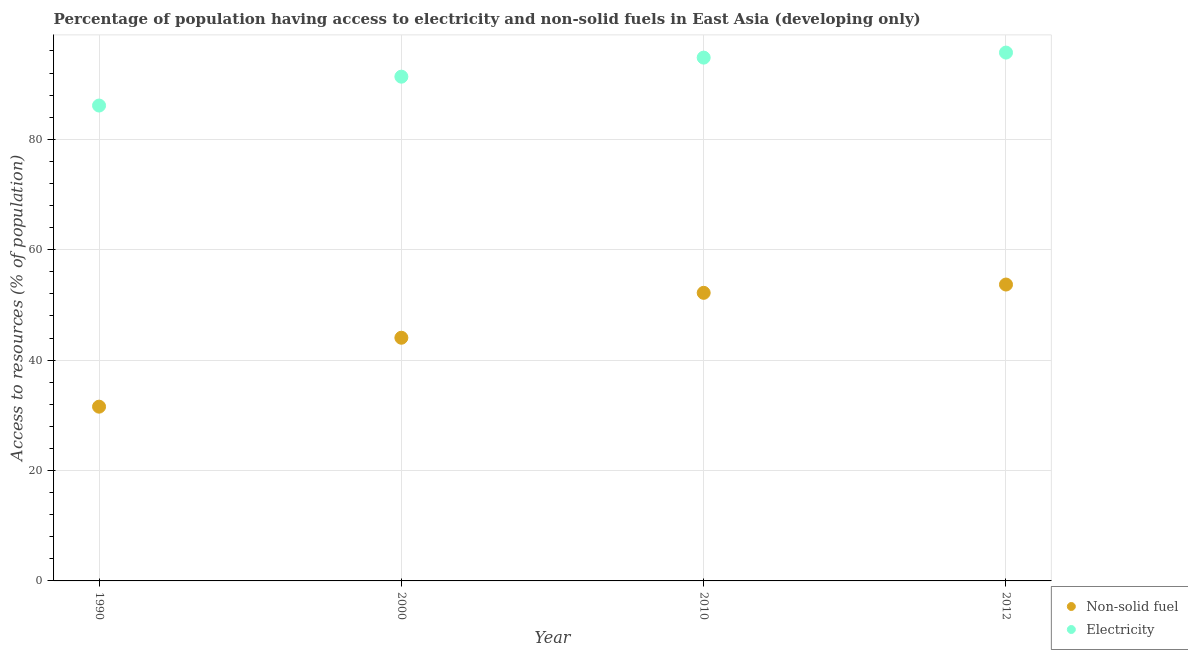What is the percentage of population having access to electricity in 2012?
Your response must be concise. 95.71. Across all years, what is the maximum percentage of population having access to electricity?
Make the answer very short. 95.71. Across all years, what is the minimum percentage of population having access to electricity?
Ensure brevity in your answer.  86.12. In which year was the percentage of population having access to non-solid fuel minimum?
Offer a terse response. 1990. What is the total percentage of population having access to non-solid fuel in the graph?
Provide a succinct answer. 181.5. What is the difference between the percentage of population having access to electricity in 1990 and that in 2000?
Your response must be concise. -5.23. What is the difference between the percentage of population having access to non-solid fuel in 2012 and the percentage of population having access to electricity in 1990?
Make the answer very short. -32.43. What is the average percentage of population having access to non-solid fuel per year?
Your answer should be very brief. 45.38. In the year 1990, what is the difference between the percentage of population having access to electricity and percentage of population having access to non-solid fuel?
Your response must be concise. 54.55. In how many years, is the percentage of population having access to electricity greater than 36 %?
Provide a succinct answer. 4. What is the ratio of the percentage of population having access to electricity in 2000 to that in 2010?
Provide a succinct answer. 0.96. Is the percentage of population having access to electricity in 2000 less than that in 2012?
Your answer should be very brief. Yes. Is the difference between the percentage of population having access to non-solid fuel in 2000 and 2010 greater than the difference between the percentage of population having access to electricity in 2000 and 2010?
Ensure brevity in your answer.  No. What is the difference between the highest and the second highest percentage of population having access to non-solid fuel?
Your answer should be compact. 1.5. What is the difference between the highest and the lowest percentage of population having access to electricity?
Provide a short and direct response. 9.59. Is the sum of the percentage of population having access to non-solid fuel in 2000 and 2010 greater than the maximum percentage of population having access to electricity across all years?
Offer a very short reply. Yes. Does the percentage of population having access to non-solid fuel monotonically increase over the years?
Give a very brief answer. Yes. Is the percentage of population having access to non-solid fuel strictly greater than the percentage of population having access to electricity over the years?
Keep it short and to the point. No. Is the percentage of population having access to non-solid fuel strictly less than the percentage of population having access to electricity over the years?
Offer a terse response. Yes. How many years are there in the graph?
Keep it short and to the point. 4. How many legend labels are there?
Offer a terse response. 2. What is the title of the graph?
Offer a terse response. Percentage of population having access to electricity and non-solid fuels in East Asia (developing only). What is the label or title of the Y-axis?
Ensure brevity in your answer.  Access to resources (% of population). What is the Access to resources (% of population) in Non-solid fuel in 1990?
Make the answer very short. 31.57. What is the Access to resources (% of population) of Electricity in 1990?
Make the answer very short. 86.12. What is the Access to resources (% of population) in Non-solid fuel in 2000?
Offer a terse response. 44.05. What is the Access to resources (% of population) in Electricity in 2000?
Your answer should be compact. 91.35. What is the Access to resources (% of population) of Non-solid fuel in 2010?
Ensure brevity in your answer.  52.19. What is the Access to resources (% of population) in Electricity in 2010?
Your answer should be very brief. 94.8. What is the Access to resources (% of population) of Non-solid fuel in 2012?
Offer a very short reply. 53.69. What is the Access to resources (% of population) in Electricity in 2012?
Your answer should be very brief. 95.71. Across all years, what is the maximum Access to resources (% of population) in Non-solid fuel?
Ensure brevity in your answer.  53.69. Across all years, what is the maximum Access to resources (% of population) of Electricity?
Your answer should be compact. 95.71. Across all years, what is the minimum Access to resources (% of population) of Non-solid fuel?
Provide a succinct answer. 31.57. Across all years, what is the minimum Access to resources (% of population) in Electricity?
Offer a very short reply. 86.12. What is the total Access to resources (% of population) in Non-solid fuel in the graph?
Keep it short and to the point. 181.5. What is the total Access to resources (% of population) of Electricity in the graph?
Give a very brief answer. 367.98. What is the difference between the Access to resources (% of population) in Non-solid fuel in 1990 and that in 2000?
Keep it short and to the point. -12.49. What is the difference between the Access to resources (% of population) in Electricity in 1990 and that in 2000?
Your answer should be compact. -5.23. What is the difference between the Access to resources (% of population) of Non-solid fuel in 1990 and that in 2010?
Ensure brevity in your answer.  -20.62. What is the difference between the Access to resources (% of population) of Electricity in 1990 and that in 2010?
Keep it short and to the point. -8.68. What is the difference between the Access to resources (% of population) in Non-solid fuel in 1990 and that in 2012?
Your response must be concise. -22.12. What is the difference between the Access to resources (% of population) of Electricity in 1990 and that in 2012?
Provide a succinct answer. -9.59. What is the difference between the Access to resources (% of population) of Non-solid fuel in 2000 and that in 2010?
Keep it short and to the point. -8.14. What is the difference between the Access to resources (% of population) of Electricity in 2000 and that in 2010?
Ensure brevity in your answer.  -3.45. What is the difference between the Access to resources (% of population) of Non-solid fuel in 2000 and that in 2012?
Provide a succinct answer. -9.64. What is the difference between the Access to resources (% of population) of Electricity in 2000 and that in 2012?
Offer a very short reply. -4.36. What is the difference between the Access to resources (% of population) in Non-solid fuel in 2010 and that in 2012?
Provide a succinct answer. -1.5. What is the difference between the Access to resources (% of population) in Electricity in 2010 and that in 2012?
Keep it short and to the point. -0.91. What is the difference between the Access to resources (% of population) of Non-solid fuel in 1990 and the Access to resources (% of population) of Electricity in 2000?
Ensure brevity in your answer.  -59.78. What is the difference between the Access to resources (% of population) of Non-solid fuel in 1990 and the Access to resources (% of population) of Electricity in 2010?
Your response must be concise. -63.23. What is the difference between the Access to resources (% of population) of Non-solid fuel in 1990 and the Access to resources (% of population) of Electricity in 2012?
Provide a short and direct response. -64.15. What is the difference between the Access to resources (% of population) in Non-solid fuel in 2000 and the Access to resources (% of population) in Electricity in 2010?
Your answer should be compact. -50.75. What is the difference between the Access to resources (% of population) of Non-solid fuel in 2000 and the Access to resources (% of population) of Electricity in 2012?
Offer a very short reply. -51.66. What is the difference between the Access to resources (% of population) of Non-solid fuel in 2010 and the Access to resources (% of population) of Electricity in 2012?
Make the answer very short. -43.52. What is the average Access to resources (% of population) of Non-solid fuel per year?
Give a very brief answer. 45.38. What is the average Access to resources (% of population) in Electricity per year?
Give a very brief answer. 92. In the year 1990, what is the difference between the Access to resources (% of population) in Non-solid fuel and Access to resources (% of population) in Electricity?
Provide a short and direct response. -54.55. In the year 2000, what is the difference between the Access to resources (% of population) of Non-solid fuel and Access to resources (% of population) of Electricity?
Offer a very short reply. -47.3. In the year 2010, what is the difference between the Access to resources (% of population) of Non-solid fuel and Access to resources (% of population) of Electricity?
Offer a terse response. -42.61. In the year 2012, what is the difference between the Access to resources (% of population) in Non-solid fuel and Access to resources (% of population) in Electricity?
Provide a short and direct response. -42.02. What is the ratio of the Access to resources (% of population) in Non-solid fuel in 1990 to that in 2000?
Your response must be concise. 0.72. What is the ratio of the Access to resources (% of population) of Electricity in 1990 to that in 2000?
Your response must be concise. 0.94. What is the ratio of the Access to resources (% of population) of Non-solid fuel in 1990 to that in 2010?
Give a very brief answer. 0.6. What is the ratio of the Access to resources (% of population) of Electricity in 1990 to that in 2010?
Offer a terse response. 0.91. What is the ratio of the Access to resources (% of population) of Non-solid fuel in 1990 to that in 2012?
Your answer should be compact. 0.59. What is the ratio of the Access to resources (% of population) of Electricity in 1990 to that in 2012?
Your response must be concise. 0.9. What is the ratio of the Access to resources (% of population) of Non-solid fuel in 2000 to that in 2010?
Your response must be concise. 0.84. What is the ratio of the Access to resources (% of population) of Electricity in 2000 to that in 2010?
Your response must be concise. 0.96. What is the ratio of the Access to resources (% of population) in Non-solid fuel in 2000 to that in 2012?
Your response must be concise. 0.82. What is the ratio of the Access to resources (% of population) of Electricity in 2000 to that in 2012?
Give a very brief answer. 0.95. What is the ratio of the Access to resources (% of population) in Non-solid fuel in 2010 to that in 2012?
Your answer should be very brief. 0.97. What is the difference between the highest and the second highest Access to resources (% of population) of Non-solid fuel?
Your answer should be compact. 1.5. What is the difference between the highest and the second highest Access to resources (% of population) in Electricity?
Offer a terse response. 0.91. What is the difference between the highest and the lowest Access to resources (% of population) in Non-solid fuel?
Your answer should be very brief. 22.12. What is the difference between the highest and the lowest Access to resources (% of population) of Electricity?
Offer a terse response. 9.59. 